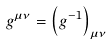<formula> <loc_0><loc_0><loc_500><loc_500>g ^ { \mu \nu } = \left ( g ^ { - 1 } \right ) _ { \mu \nu }</formula> 